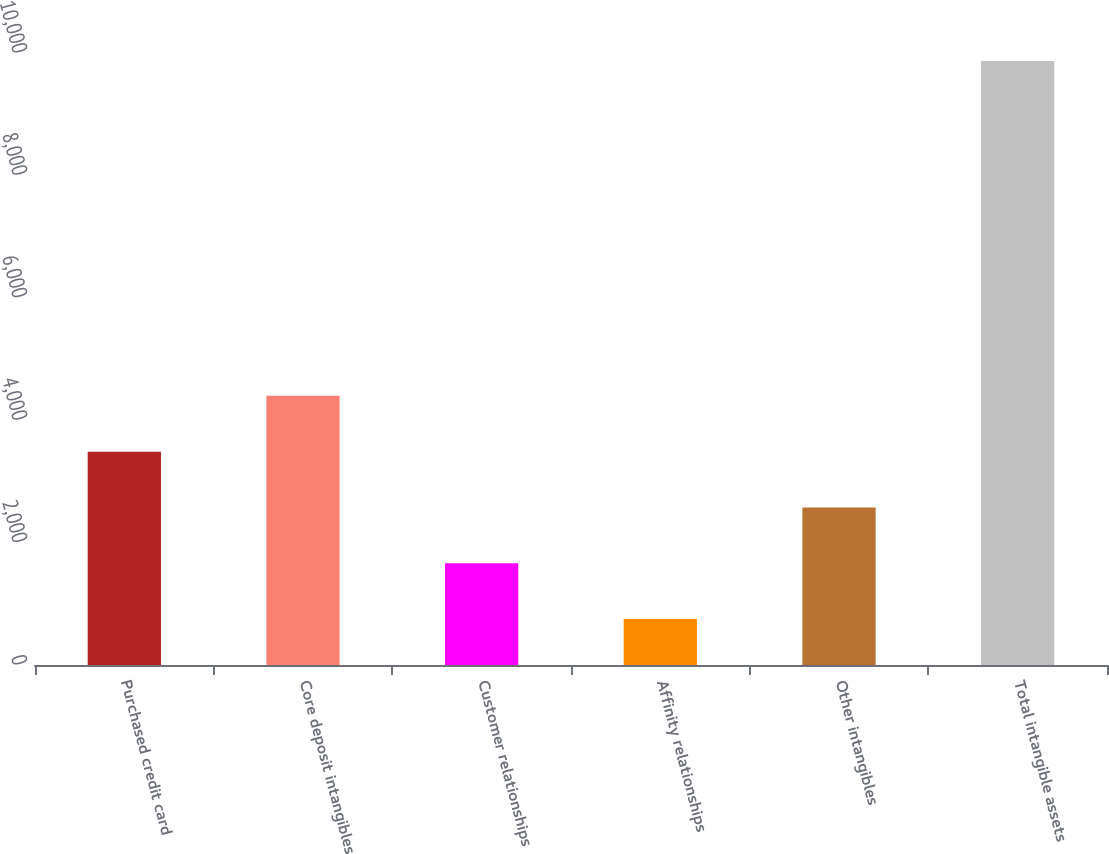<chart> <loc_0><loc_0><loc_500><loc_500><bar_chart><fcel>Purchased credit card<fcel>Core deposit intangibles<fcel>Customer relationships<fcel>Affinity relationships<fcel>Other intangibles<fcel>Total intangible assets<nl><fcel>3486.1<fcel>4397.8<fcel>1662.7<fcel>751<fcel>2574.4<fcel>9868<nl></chart> 